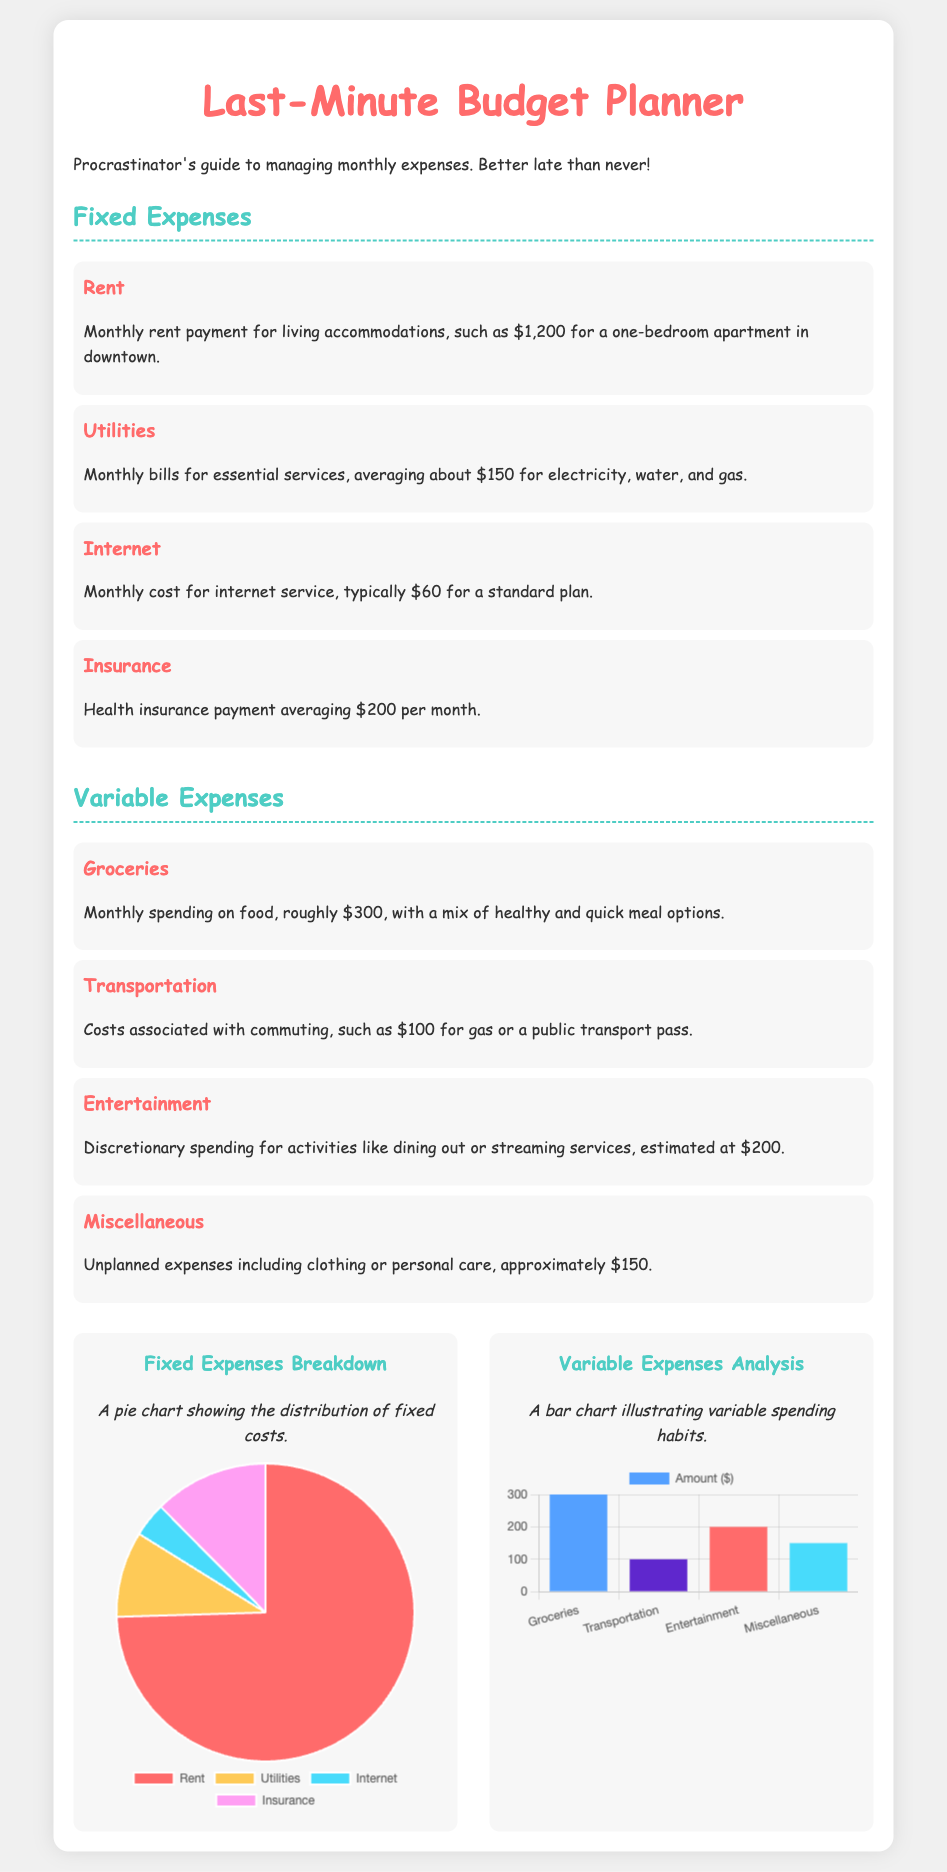What is the total amount for fixed expenses? The total fixed expenses can be calculated by adding all fixed costs: $1200 (Rent) + $150 (Utilities) + $60 (Internet) + $200 (Insurance) = $1610.
Answer: $1610 How much is the monthly rent payment? The document specifies the monthly rent payment is $1,200.
Answer: $1,200 What is the estimated spending on entertainment? The document states the estimated spending on entertainment is $200.
Answer: $200 Which expense has the highest percentage in the fixed expenses chart? From the pie chart, it is clear that Rent has the largest portion of fixed expenses at $1200.
Answer: Rent How much are the total variable expenses? The total variable expenses can be found by adding all variable costs: $300 (Groceries) + $100 (Transportation) + $200 (Entertainment) + $150 (Miscellaneous) = $750.
Answer: $750 What are the four categories of variable expenses? The categories for variable expenses are Groceries, Transportation, Entertainment, and Miscellaneous.
Answer: Groceries, Transportation, Entertainment, Miscellaneous What color represents the Internet expense in the fixed expenses chart? The color representing the Internet expense in the pie chart is light blue, as noted in the document.
Answer: Light blue How many types of charts are included in the document? The document includes two types of charts: a pie chart and a bar chart.
Answer: Two What is the pie chart used for in the document? The pie chart is used to illustrate the breakdown of fixed expenses.
Answer: Breakdown of fixed expenses 